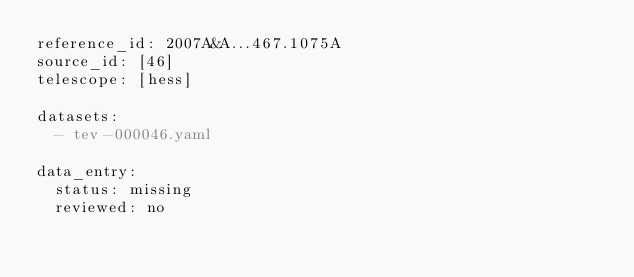<code> <loc_0><loc_0><loc_500><loc_500><_YAML_>reference_id: 2007A&A...467.1075A
source_id: [46]
telescope: [hess]

datasets:
  - tev-000046.yaml

data_entry:
  status: missing
  reviewed: no
</code> 